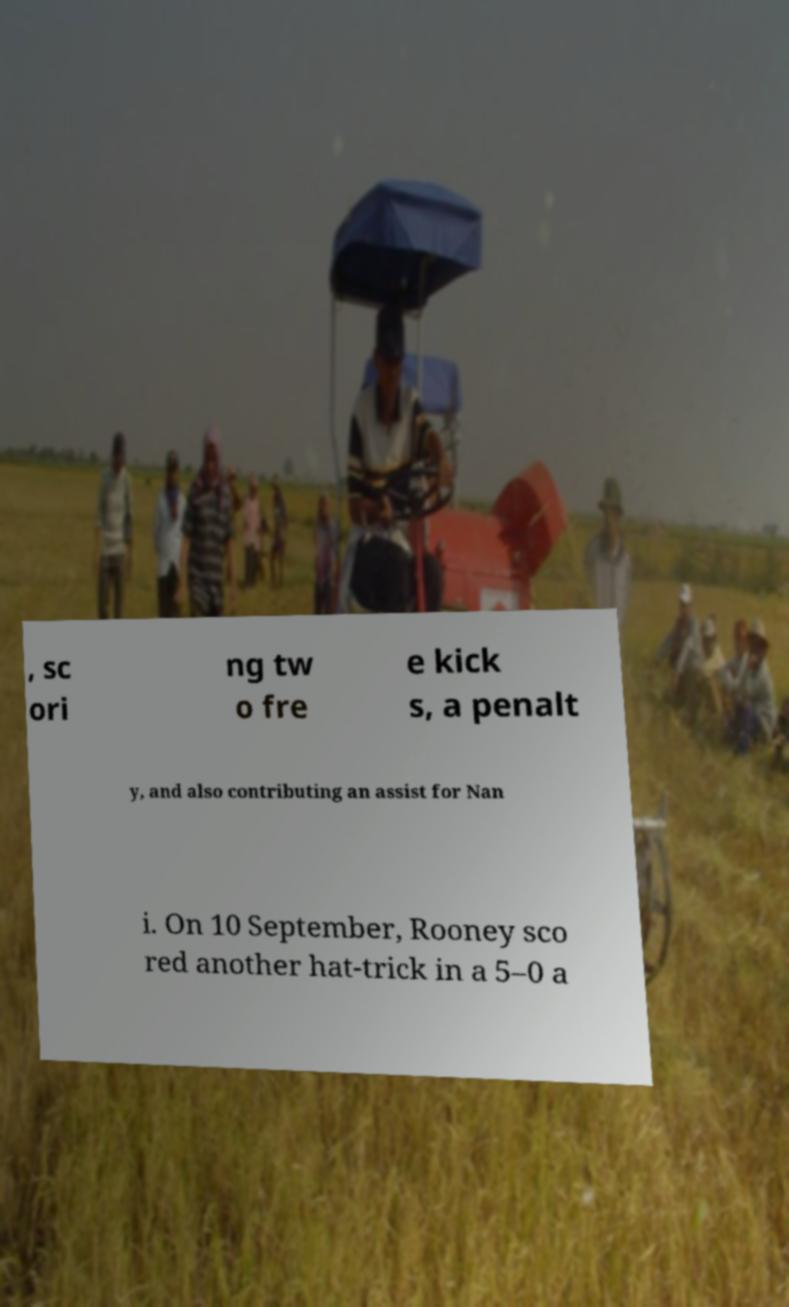Please read and relay the text visible in this image. What does it say? , sc ori ng tw o fre e kick s, a penalt y, and also contributing an assist for Nan i. On 10 September, Rooney sco red another hat-trick in a 5–0 a 